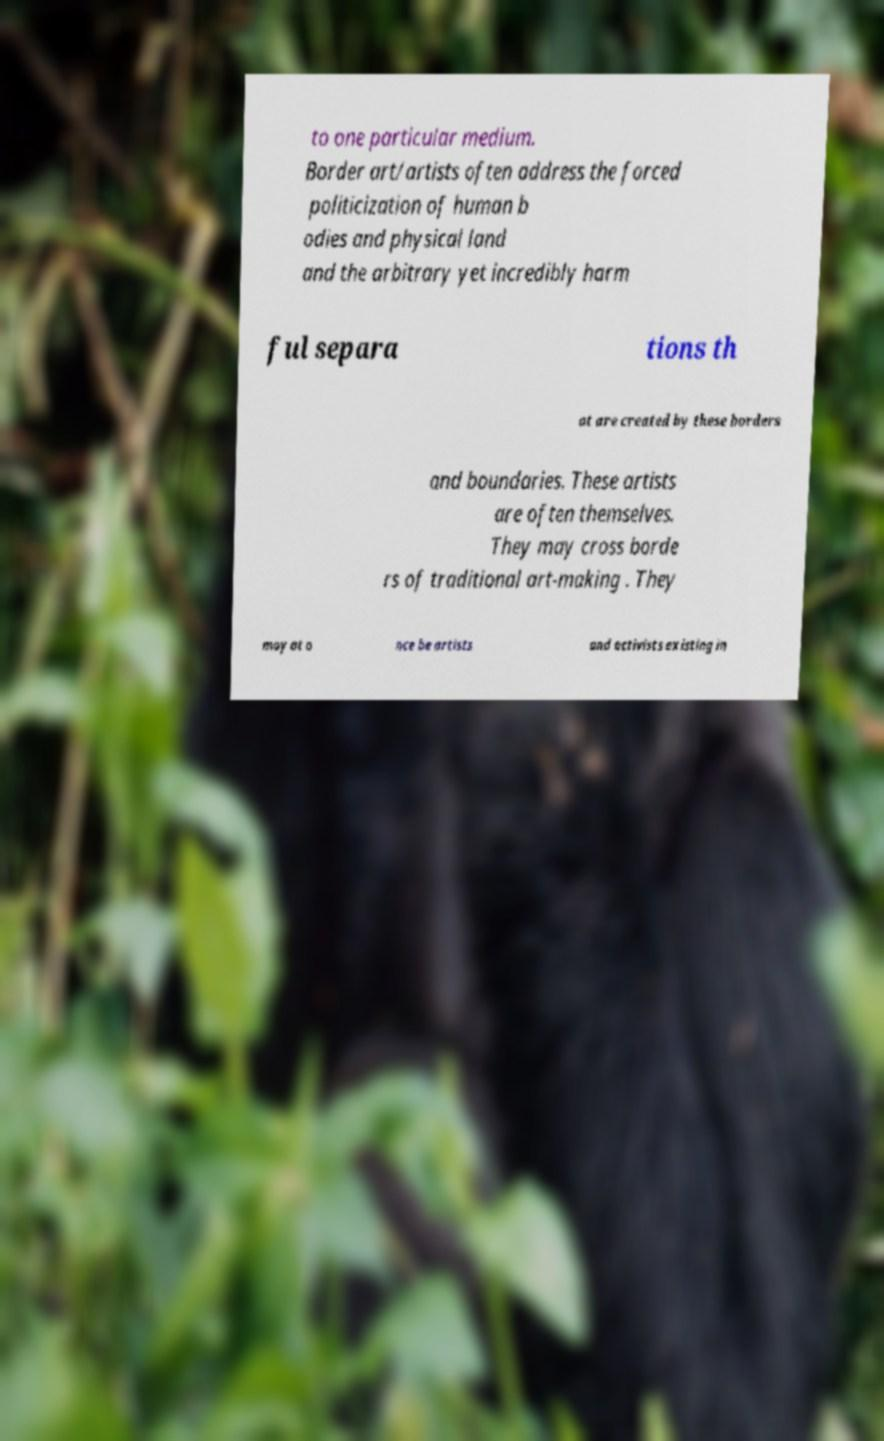Please identify and transcribe the text found in this image. to one particular medium. Border art/artists often address the forced politicization of human b odies and physical land and the arbitrary yet incredibly harm ful separa tions th at are created by these borders and boundaries. These artists are often themselves. They may cross borde rs of traditional art-making . They may at o nce be artists and activists existing in 